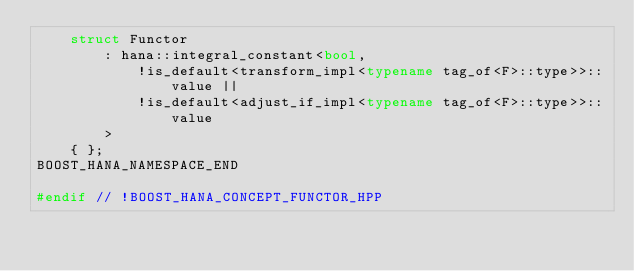<code> <loc_0><loc_0><loc_500><loc_500><_C++_>    struct Functor
        : hana::integral_constant<bool,
            !is_default<transform_impl<typename tag_of<F>::type>>::value ||
            !is_default<adjust_if_impl<typename tag_of<F>::type>>::value
        >
    { };
BOOST_HANA_NAMESPACE_END

#endif // !BOOST_HANA_CONCEPT_FUNCTOR_HPP
</code> 